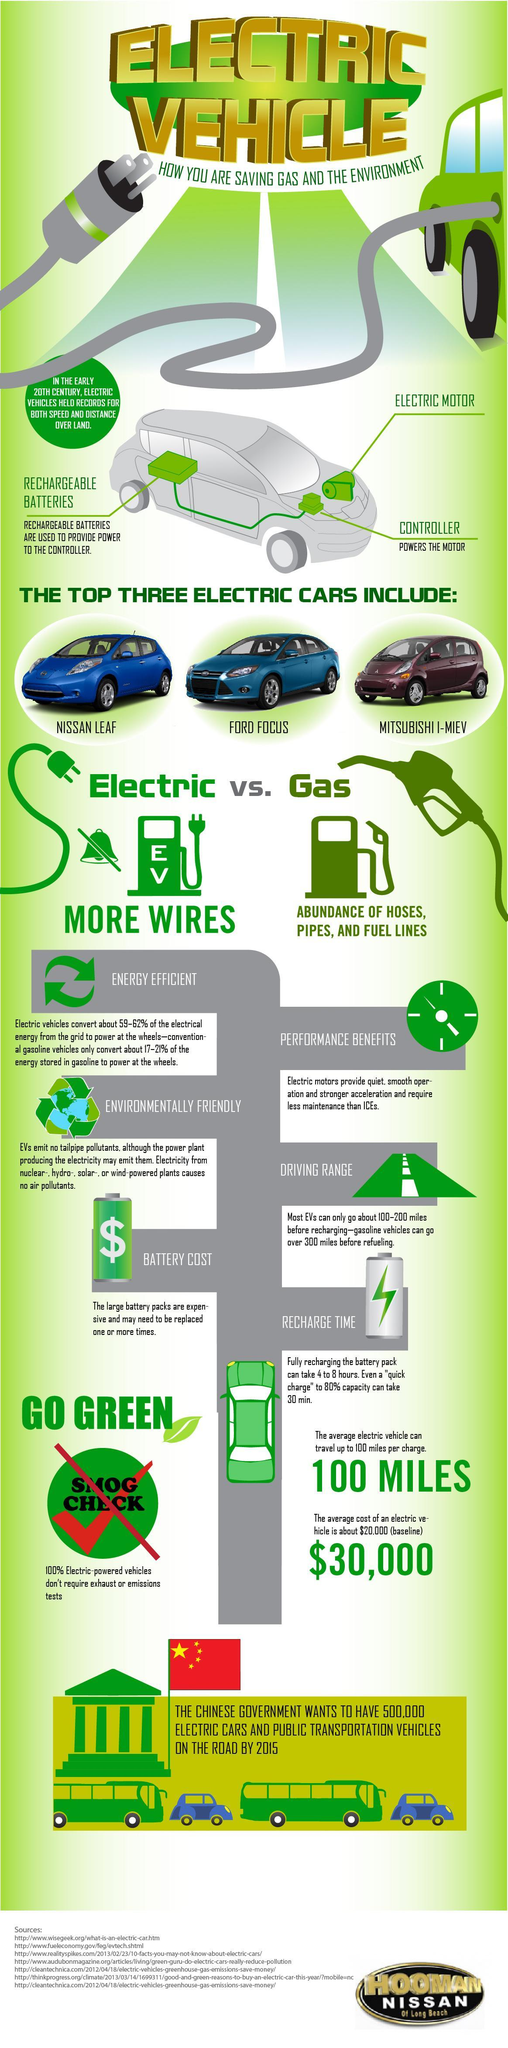Which are the main parts of an electric vehicle?
Answer the question with a short phrase. RECHARGEABLE BATTERIES, ELECTRIC MOTOR, CONTROLLER How many sources are listed at the bottom? 7 